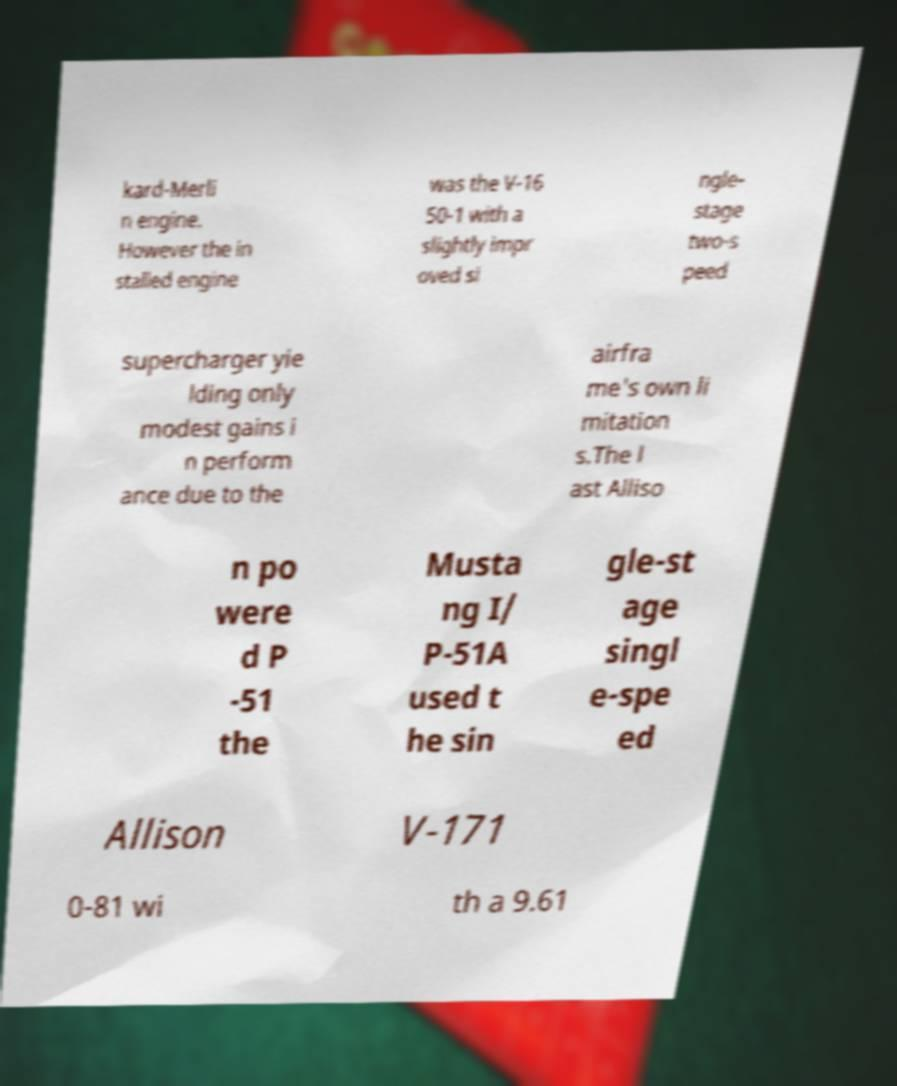What messages or text are displayed in this image? I need them in a readable, typed format. kard-Merli n engine. However the in stalled engine was the V-16 50-1 with a slightly impr oved si ngle- stage two-s peed supercharger yie lding only modest gains i n perform ance due to the airfra me's own li mitation s.The l ast Alliso n po were d P -51 the Musta ng I/ P-51A used t he sin gle-st age singl e-spe ed Allison V-171 0-81 wi th a 9.61 